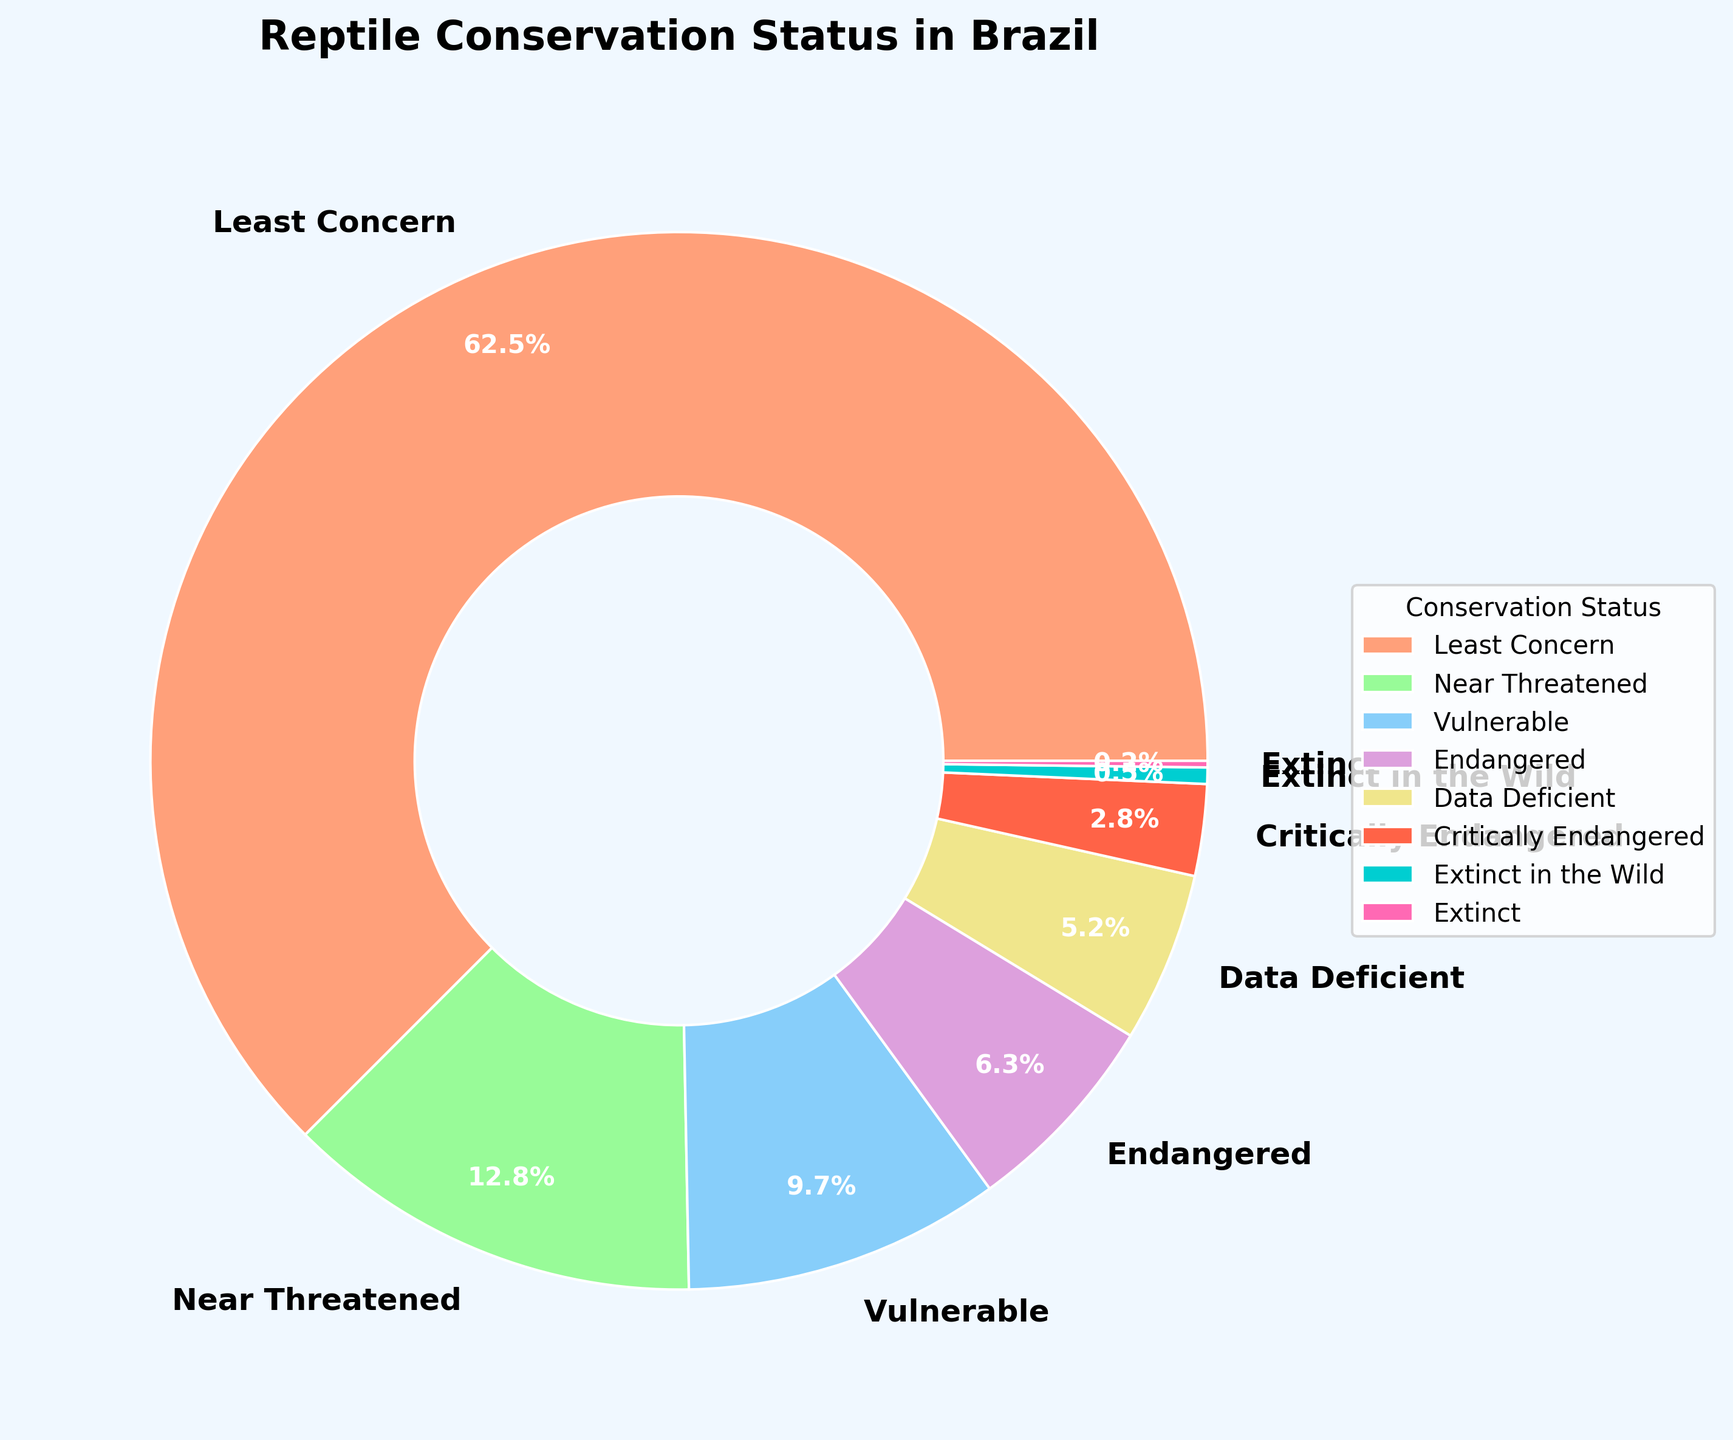What percentage of reptiles in Brazil are classified as either Vulnerable or Endangered? Adding the percentages of Vulnerable (9.7%) and Endangered (6.3%) reptiles, the total is 9.7% + 6.3% = 16%
Answer: 16% Which conservation status has the smallest percentage of reptiles? According to the pie chart, Extinct has the smallest percentage, at 0.2%
Answer: Extinct How many conservation statuses have a percentage greater than 10%? From the pie chart, Least Concern (62.5%) and Near Threatened (12.8%) are the only categories with percentages greater than 10%
Answer: 2 Is the percentage of Near Threatened reptiles higher than the combined percentage of Critically Endangered and Extinct in the Wild? The percentage for Near Threatened is 12.8%. The combined percentage of Critically Endangered (2.8%) and Extinct in the Wild (0.5%) is 2.8% + 0.5% = 3.3%, which is less than 12.8%
Answer: Yes What is the combined percentage of reptiles classified as Extinct and Data Deficient? Adding the percentages for Extinct (0.2%) and Data Deficient (5.2%) gives 0.2% + 5.2% = 5.4%
Answer: 5.4% Compare the percentage of Vulnerable reptiles with the percentage of Endangered reptiles. Which is higher and by how much? Vulnerable has a percentage of 9.7% and Endangered has 6.3%. The difference is 9.7% - 6.3% = 3.4%. Vulnerable is higher by 3.4%
Answer: Vulnerable is higher by 3.4% Which category has a percentage more than triple that of Critically Endangered reptiles? Critically Endangered has a percentage of 2.8%. Categories with more than triple of this (2.8% x 3 = 8.4%) are Least Concern (62.5%) and Near Threatened (12.8%)
Answer: Least Concern and Near Threatened What color represents the 'Vulnerable' category in the pie chart? The pie chart color for the 'Vulnerable' category is blue
Answer: Blue What is the sum of the percentages for Critically Endangered and Extinct categories? Critically Endangered is 2.8% and Extinct is 0.2%. Adding these together, 2.8% + 0.2% = 3.0%
Answer: 3.0% How does the percentage of Least Concern compare to all other categories combined? The percentage for Least Concern is 62.5%. Summing the other categories: Near Threatened (12.8%), Vulnerable (9.7%), Endangered (6.3%), Data Deficient (5.2%), Critically Endangered (2.8%), Extinct in the Wild (0.5%), and Extinct (0.2%) gives 12.8% + 9.7% + 6.3% + 5.2% + 2.8% + 0.5% + 0.2% = 37.5%. 62.5% is greater than 37.5%
Answer: Greater 